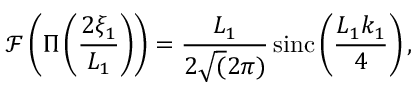<formula> <loc_0><loc_0><loc_500><loc_500>\mathcal { F } \left ( \Pi \left ( \frac { 2 \xi _ { 1 } } { L _ { 1 } } \right ) \right ) = \frac { L _ { 1 } } { 2 \sqrt { ( } 2 \pi ) } \, \sin c \left ( \frac { L _ { 1 } k _ { 1 } } { 4 } \right ) ,</formula> 